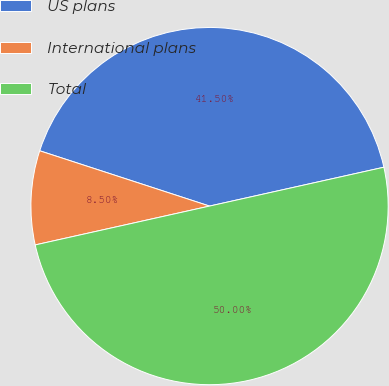Convert chart to OTSL. <chart><loc_0><loc_0><loc_500><loc_500><pie_chart><fcel>US plans<fcel>International plans<fcel>Total<nl><fcel>41.5%<fcel>8.5%<fcel>50.0%<nl></chart> 